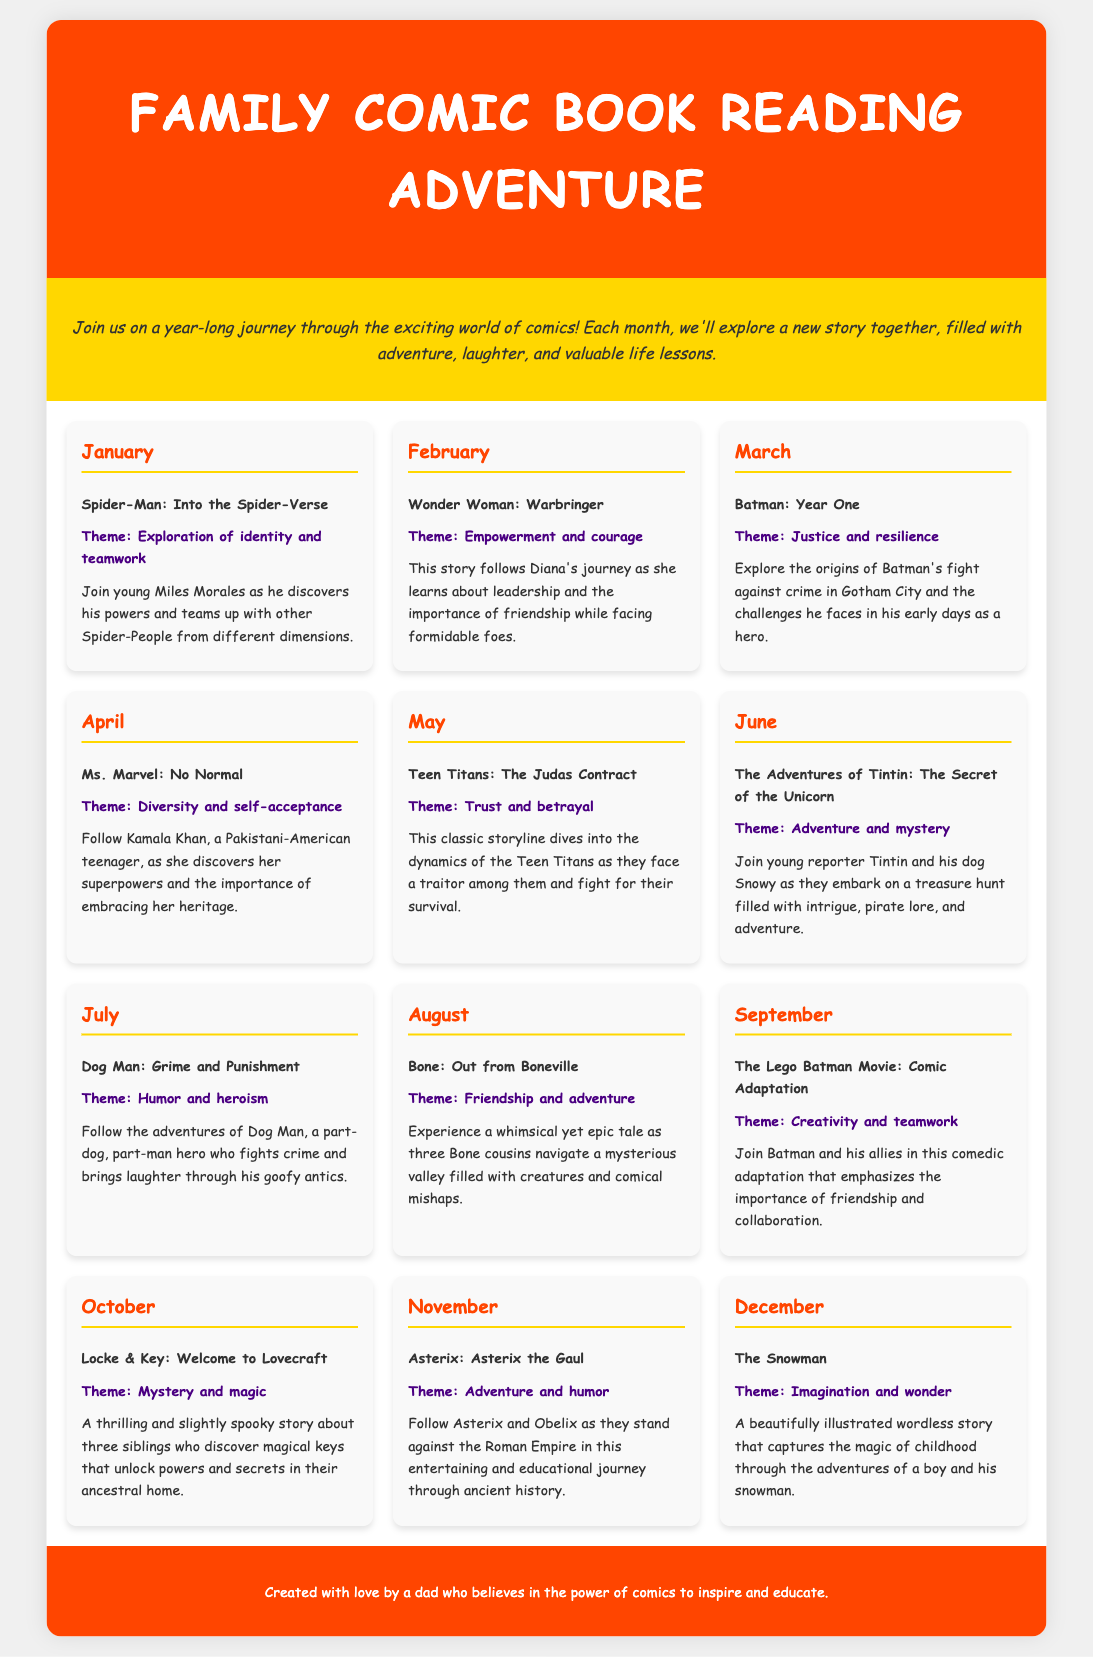what is the title of the document? The title of the document is found in the header section of the rendered page.
Answer: Family Comic Book Reading Adventure how many comic books are scheduled for reading in a year? There are twelve monthly entries in the reading schedule, indicating one comic book for each month.
Answer: twelve what is the theme of the comic book scheduled for March? The theme for March can be found with the comic title, detailing its main focus or message.
Answer: Justice and resilience who is the main character in the comic book for April? The main character for April's comic book is presented alongside the title and description.
Answer: Kamala Khan which month features the story of Asterix? The month is specified within the title and description sections, indicating when Asterix is scheduled.
Answer: November which comic book discusses the theme of friendship and adventure? The specific comic book title and its theme are detailed within the monthly entries.
Answer: Bone: Out from Boneville what is the theme of the comic scheduled for October? The theme is included in the description of the comic for the month of October.
Answer: Mystery and magic which comic features empowerment and courage? The title of the comic representing empowerment and courage is included within the February entry.
Answer: Wonder Woman: Warbringer what is the last comic scheduled in the reading list? The last comic can be determined by looking at the order and month in the reading schedule.
Answer: The Snowman 